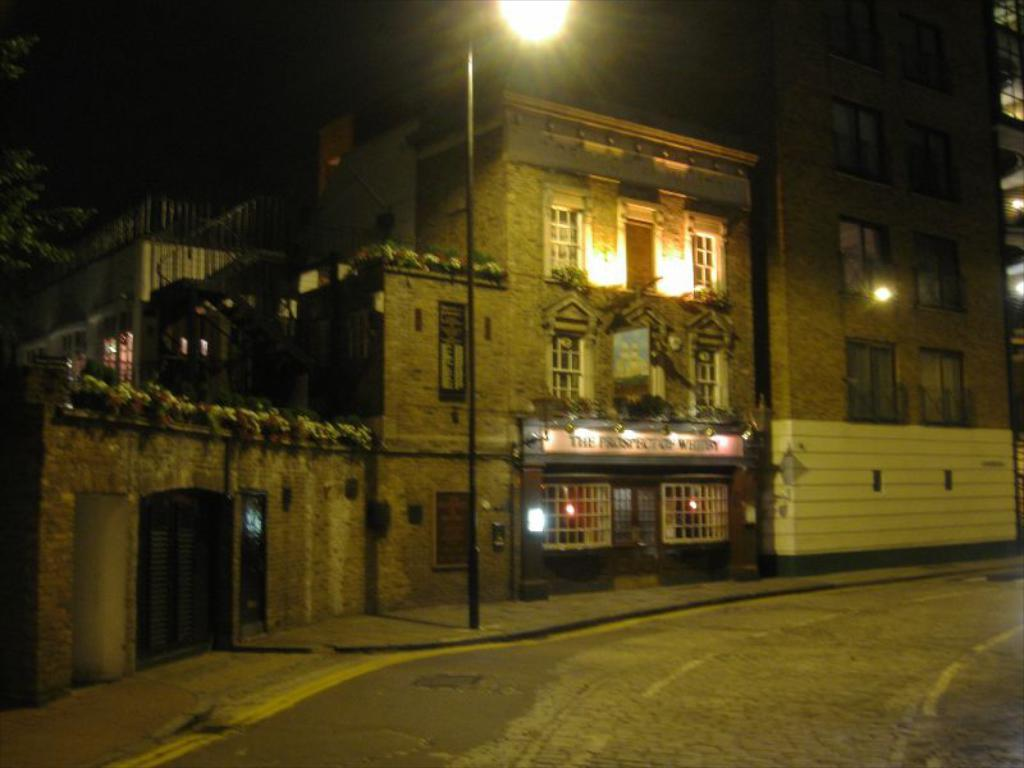What is the main feature of the image? There is a road in the image. Are there any structures near the road? Yes, there is a light pole near the road. What can be seen on the buildings in the image? There are buildings with windows in the image. Is there any additional information on one of the buildings? Yes, there is a board on one of the buildings. What type of vegetation is present in the image? There is a tree in the image. What is the color of the background in the image? The background of the image is black. What type of fuel can be seen burning in the image? There is no fuel or flame present in the image. Can you see a kitten playing near the tree in the image? There is no kitten present in the image. 